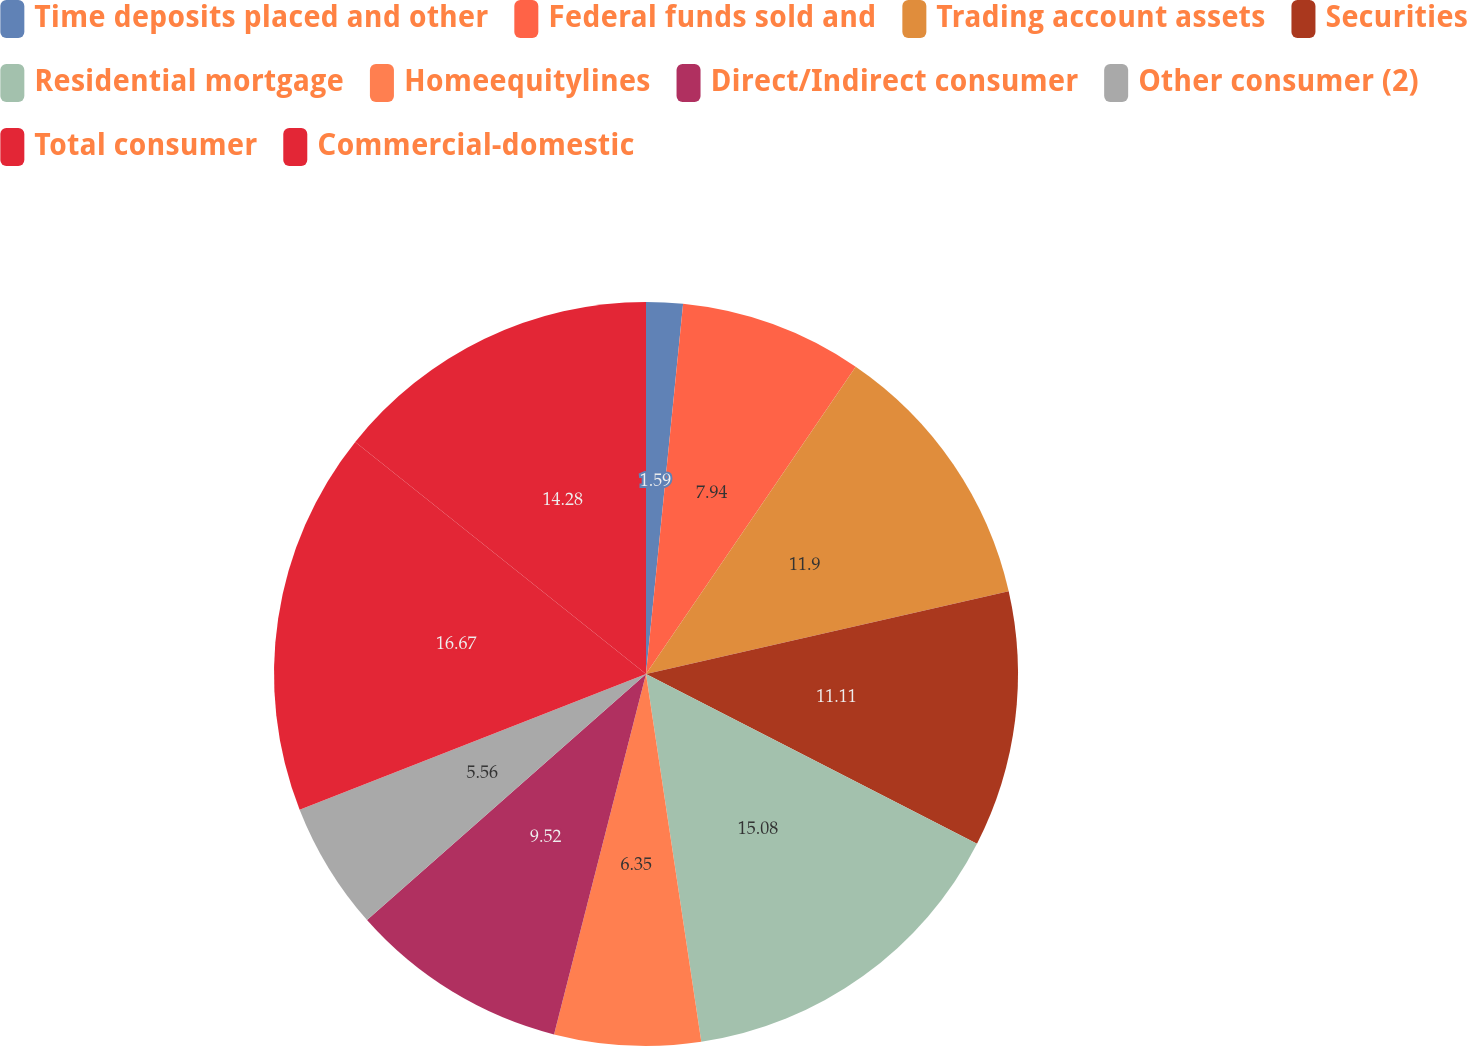Convert chart. <chart><loc_0><loc_0><loc_500><loc_500><pie_chart><fcel>Time deposits placed and other<fcel>Federal funds sold and<fcel>Trading account assets<fcel>Securities<fcel>Residential mortgage<fcel>Homeequitylines<fcel>Direct/Indirect consumer<fcel>Other consumer (2)<fcel>Total consumer<fcel>Commercial-domestic<nl><fcel>1.59%<fcel>7.94%<fcel>11.9%<fcel>11.11%<fcel>15.08%<fcel>6.35%<fcel>9.52%<fcel>5.56%<fcel>16.66%<fcel>14.28%<nl></chart> 